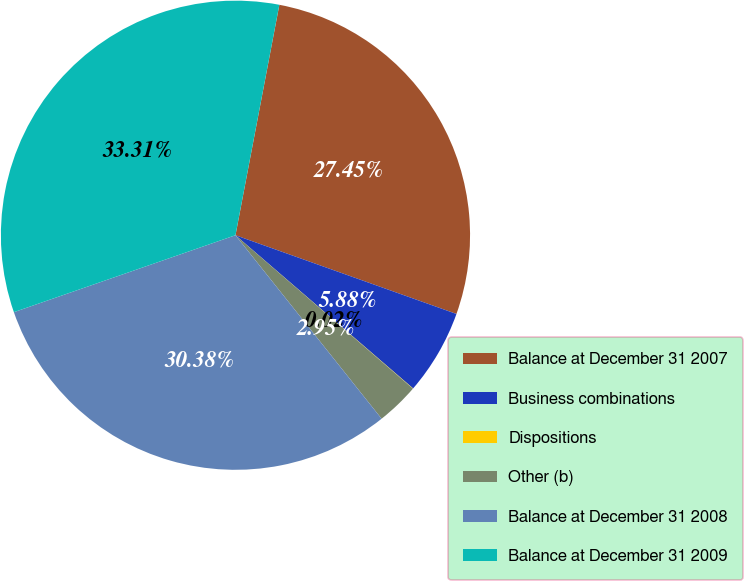Convert chart to OTSL. <chart><loc_0><loc_0><loc_500><loc_500><pie_chart><fcel>Balance at December 31 2007<fcel>Business combinations<fcel>Dispositions<fcel>Other (b)<fcel>Balance at December 31 2008<fcel>Balance at December 31 2009<nl><fcel>27.45%<fcel>5.88%<fcel>0.02%<fcel>2.95%<fcel>30.38%<fcel>33.31%<nl></chart> 